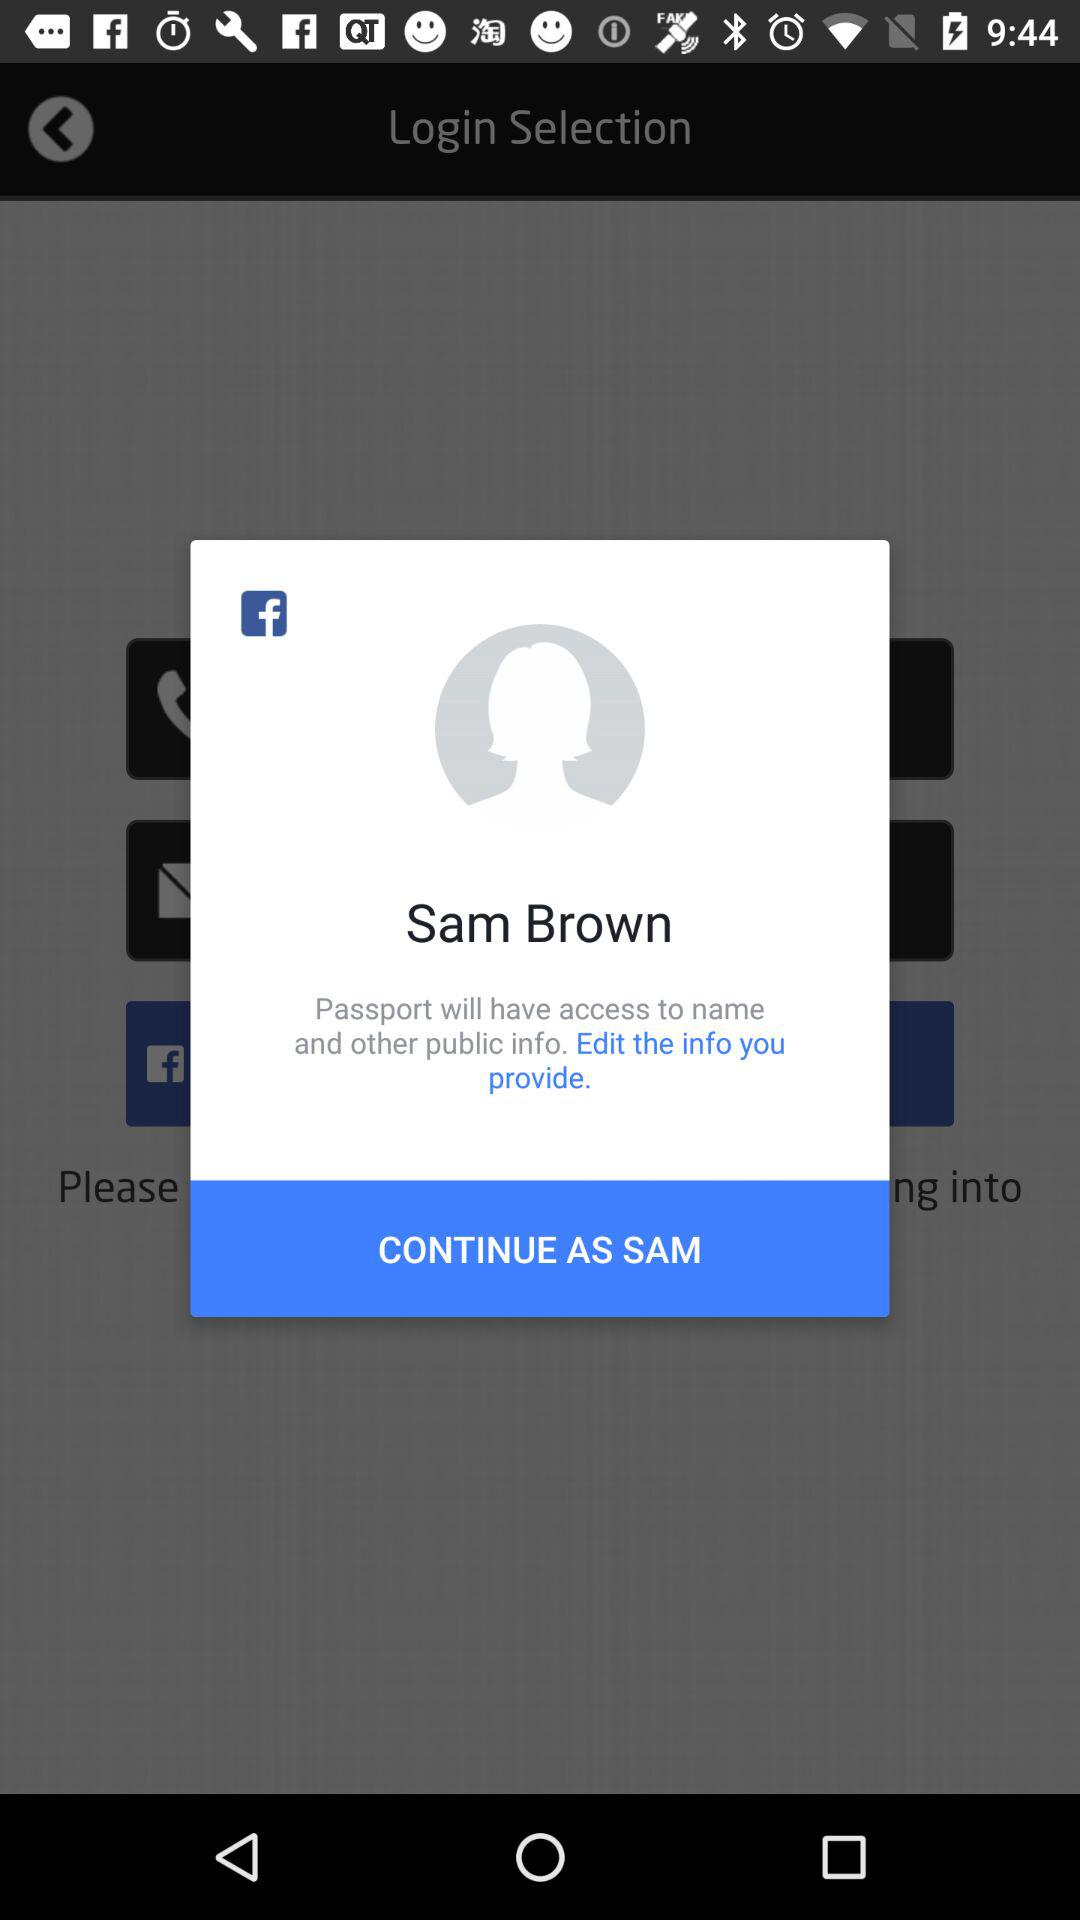What application will access the name and other public info? The application "Passport" will access the name and other public info. 